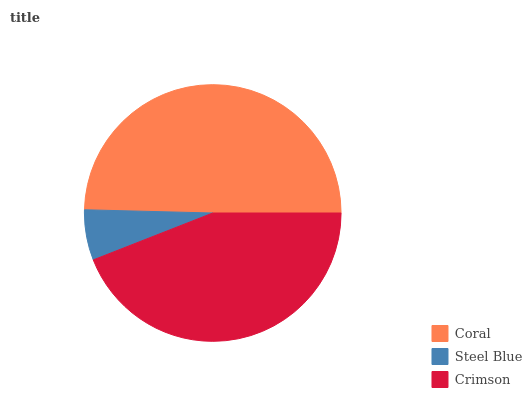Is Steel Blue the minimum?
Answer yes or no. Yes. Is Coral the maximum?
Answer yes or no. Yes. Is Crimson the minimum?
Answer yes or no. No. Is Crimson the maximum?
Answer yes or no. No. Is Crimson greater than Steel Blue?
Answer yes or no. Yes. Is Steel Blue less than Crimson?
Answer yes or no. Yes. Is Steel Blue greater than Crimson?
Answer yes or no. No. Is Crimson less than Steel Blue?
Answer yes or no. No. Is Crimson the high median?
Answer yes or no. Yes. Is Crimson the low median?
Answer yes or no. Yes. Is Coral the high median?
Answer yes or no. No. Is Steel Blue the low median?
Answer yes or no. No. 